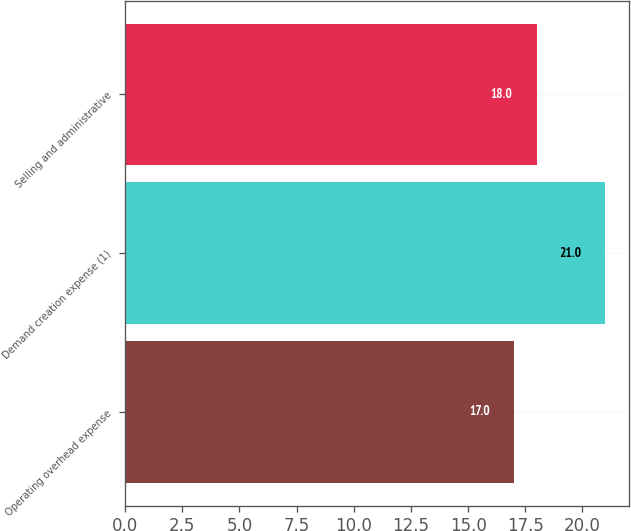Convert chart to OTSL. <chart><loc_0><loc_0><loc_500><loc_500><bar_chart><fcel>Operating overhead expense<fcel>Demand creation expense (1)<fcel>Selling and administrative<nl><fcel>17<fcel>21<fcel>18<nl></chart> 